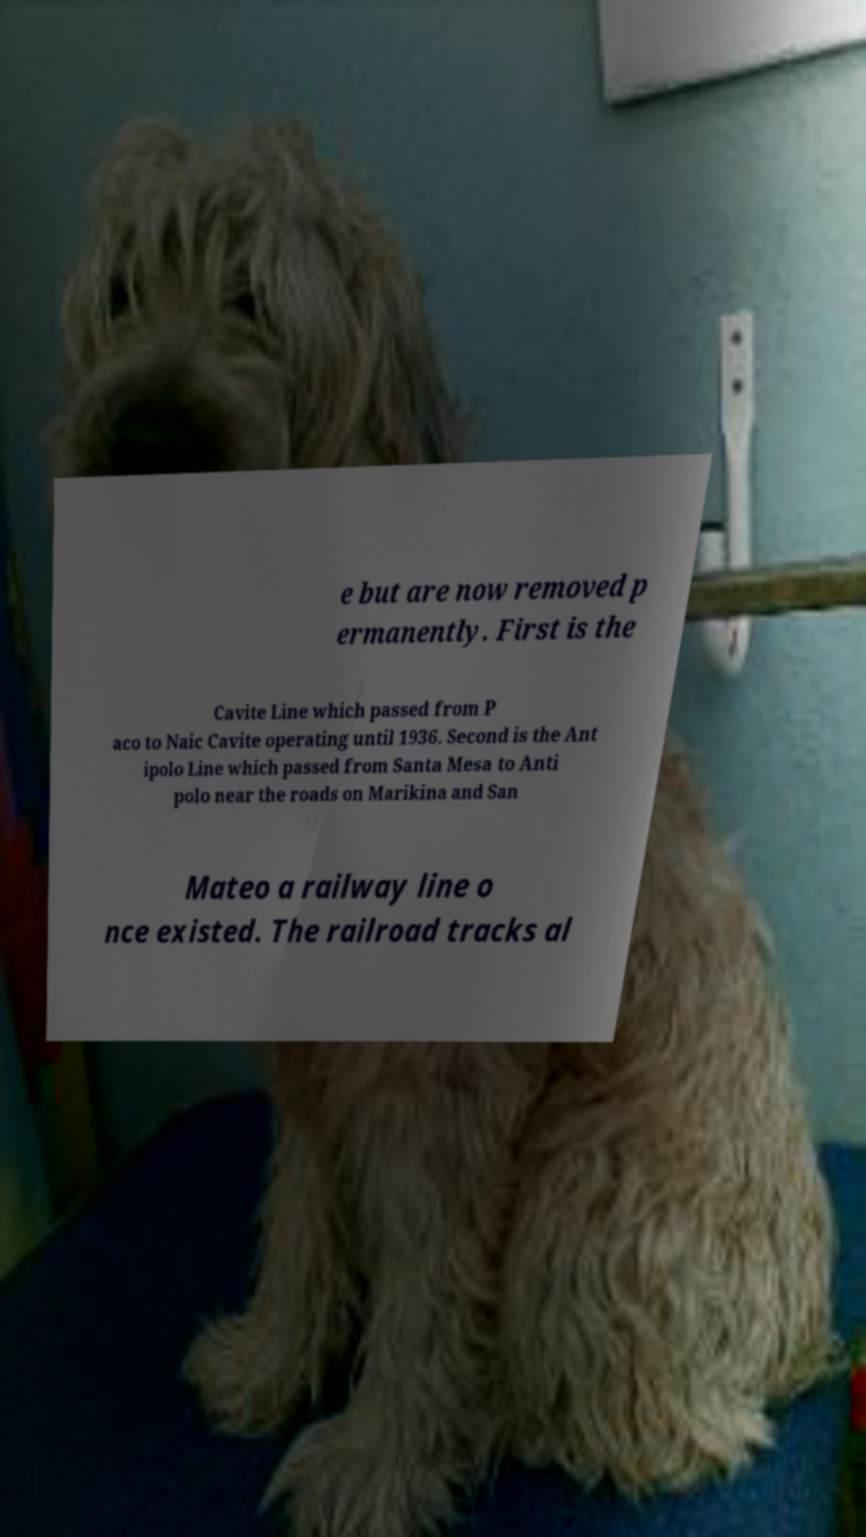Can you accurately transcribe the text from the provided image for me? e but are now removed p ermanently. First is the Cavite Line which passed from P aco to Naic Cavite operating until 1936. Second is the Ant ipolo Line which passed from Santa Mesa to Anti polo near the roads on Marikina and San Mateo a railway line o nce existed. The railroad tracks al 